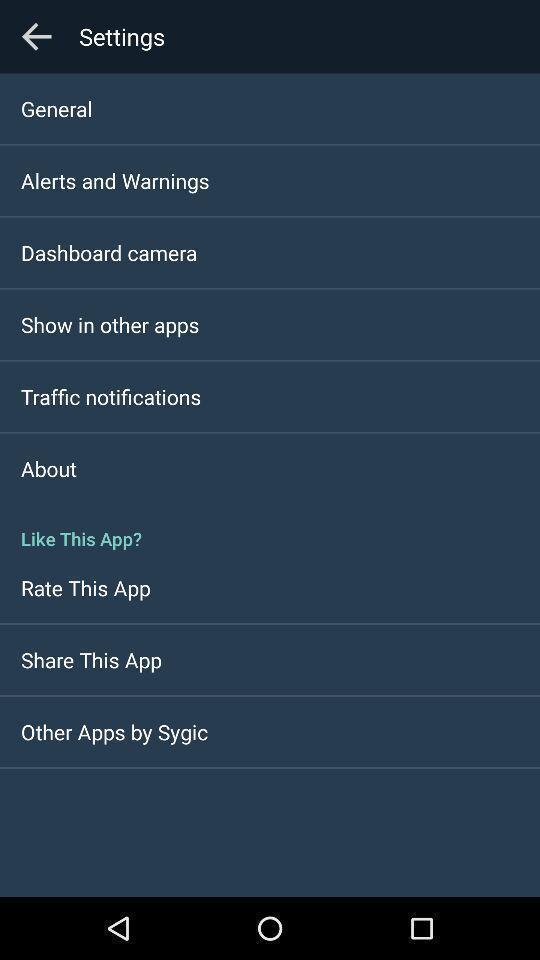Tell me what you see in this picture. Screen showing settings page. 